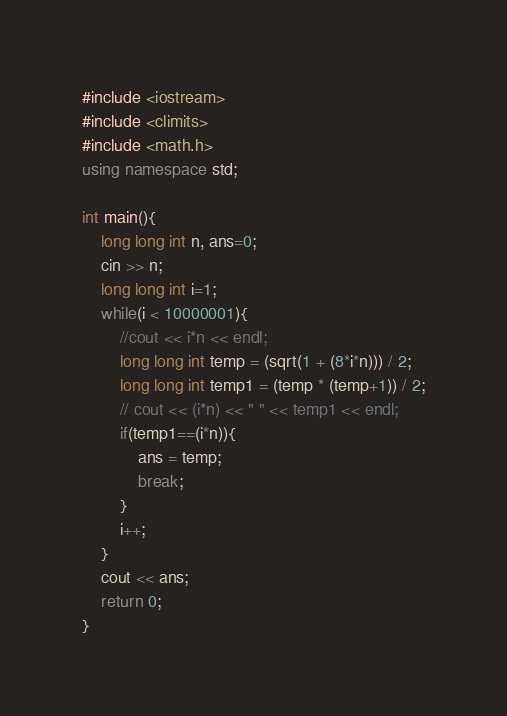<code> <loc_0><loc_0><loc_500><loc_500><_C++_>#include <iostream>
#include <climits>
#include <math.h>
using namespace std;

int main(){
    long long int n, ans=0;
    cin >> n;
    long long int i=1;
    while(i < 10000001){
        //cout << i*n << endl;
        long long int temp = (sqrt(1 + (8*i*n))) / 2;
        long long int temp1 = (temp * (temp+1)) / 2;
        // cout << (i*n) << " " << temp1 << endl;
        if(temp1==(i*n)){
            ans = temp;
            break;
        }
        i++;
    }
    cout << ans;
    return 0;
}</code> 